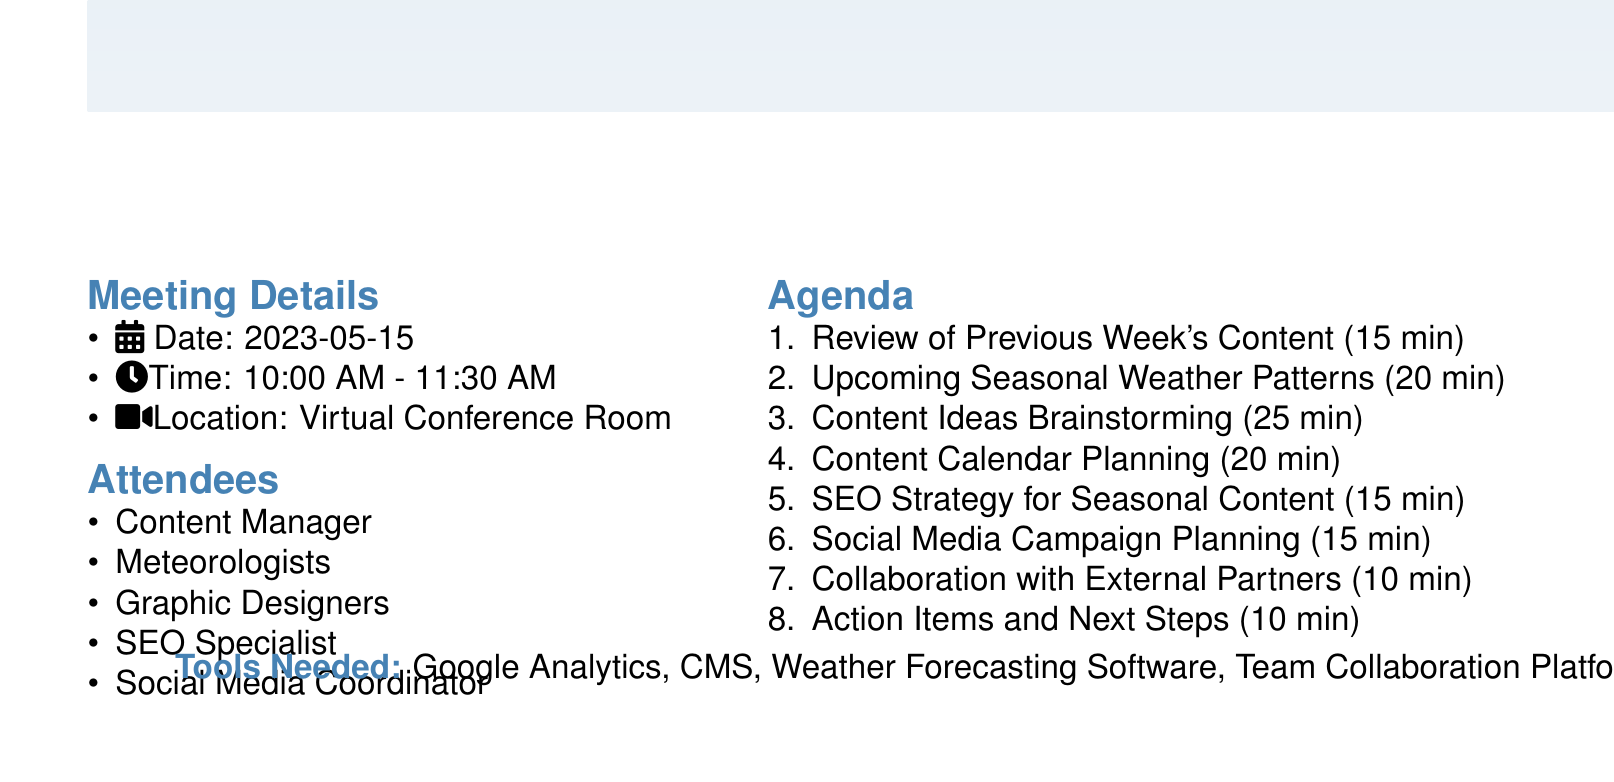What is the meeting title? The meeting title is the main heading of the agenda document.
Answer: Weekly Content Planning Meeting: Seasonal Weather Patterns Focus What is the date of the meeting? The date is specified in the meeting details section of the document.
Answer: 2023-05-15 How many attendees are listed? The number of attendees is found in the attendees section of the agenda.
Answer: 5 What is one of the agenda items related to content? This question is asking for a specific item from the agenda that pertains to content creation.
Answer: Content Ideas Brainstorming What is the duration of the "Social Media Campaign Planning" item? This duration is explicitly stated in the agenda item durations.
Answer: 15 minutes What is the focus area of the SEO strategy discussed? This requires reasoning as it asks for specific content related to SEO from the agenda.
Answer: Keyword research for seasonal weather terms Who will present the upcoming seasonal weather patterns overview? This question seeks to identify the presenter of a specific agenda item.
Answer: Lead meteorologist What is one of the platforms mentioned for the social media campaign? This question asks for specific examples from the social media campaign planning part of the agenda.
Answer: Twitter 